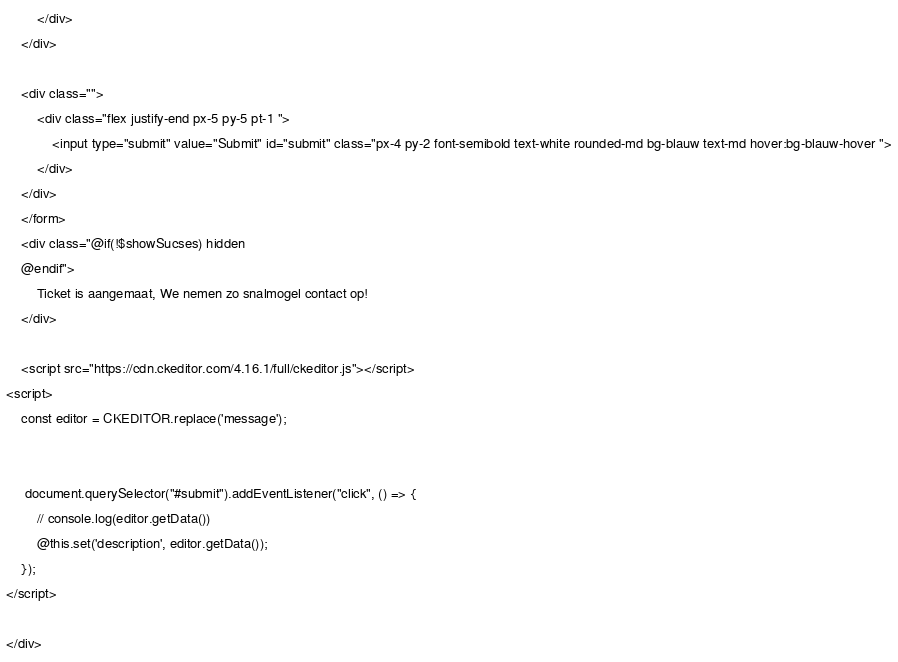<code> <loc_0><loc_0><loc_500><loc_500><_PHP_>        </div>
    </div>

    <div class="">
        <div class="flex justify-end px-5 py-5 pt-1 ">
            <input type="submit" value="Submit" id="submit" class="px-4 py-2 font-semibold text-white rounded-md bg-blauw text-md hover:bg-blauw-hover ">
        </div>
    </div>
    </form>
    <div class="@if(!$showSucses) hidden
    @endif">
        Ticket is aangemaat, We nemen zo snalmogel contact op!
    </div>

    <script src="https://cdn.ckeditor.com/4.16.1/full/ckeditor.js"></script>
<script>
    const editor = CKEDITOR.replace('message');


     document.querySelector("#submit").addEventListener("click", () => {
        // console.log(editor.getData())
        @this.set('description', editor.getData());
    });
</script>

</div>
</code> 